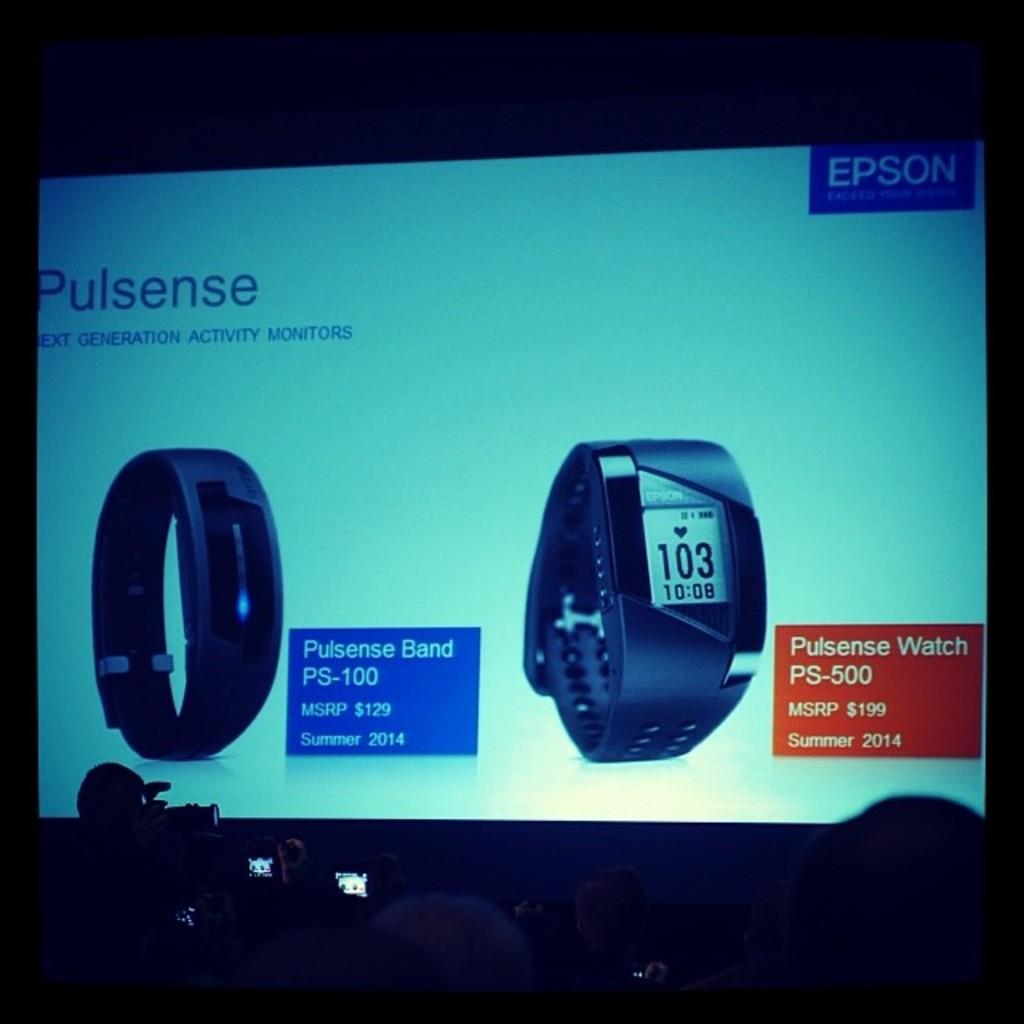What is the main object in the image? There is a screen in the image. What can be seen on the screen? The screen contains text and images of watches. Are there any people visible in the image? Yes, there are people at the bottom of the image. How many dolls are sitting on the bed in the image? There is no bed or dolls present in the image. What is the chance of winning a prize in the image? There is no mention of a prize or chance in the image. 